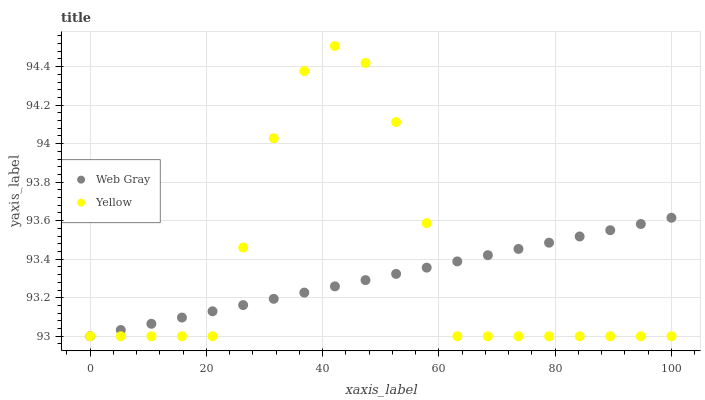Does Web Gray have the minimum area under the curve?
Answer yes or no. Yes. Does Yellow have the maximum area under the curve?
Answer yes or no. Yes. Does Yellow have the minimum area under the curve?
Answer yes or no. No. Is Web Gray the smoothest?
Answer yes or no. Yes. Is Yellow the roughest?
Answer yes or no. Yes. Is Yellow the smoothest?
Answer yes or no. No. Does Web Gray have the lowest value?
Answer yes or no. Yes. Does Yellow have the highest value?
Answer yes or no. Yes. Does Yellow intersect Web Gray?
Answer yes or no. Yes. Is Yellow less than Web Gray?
Answer yes or no. No. Is Yellow greater than Web Gray?
Answer yes or no. No. 